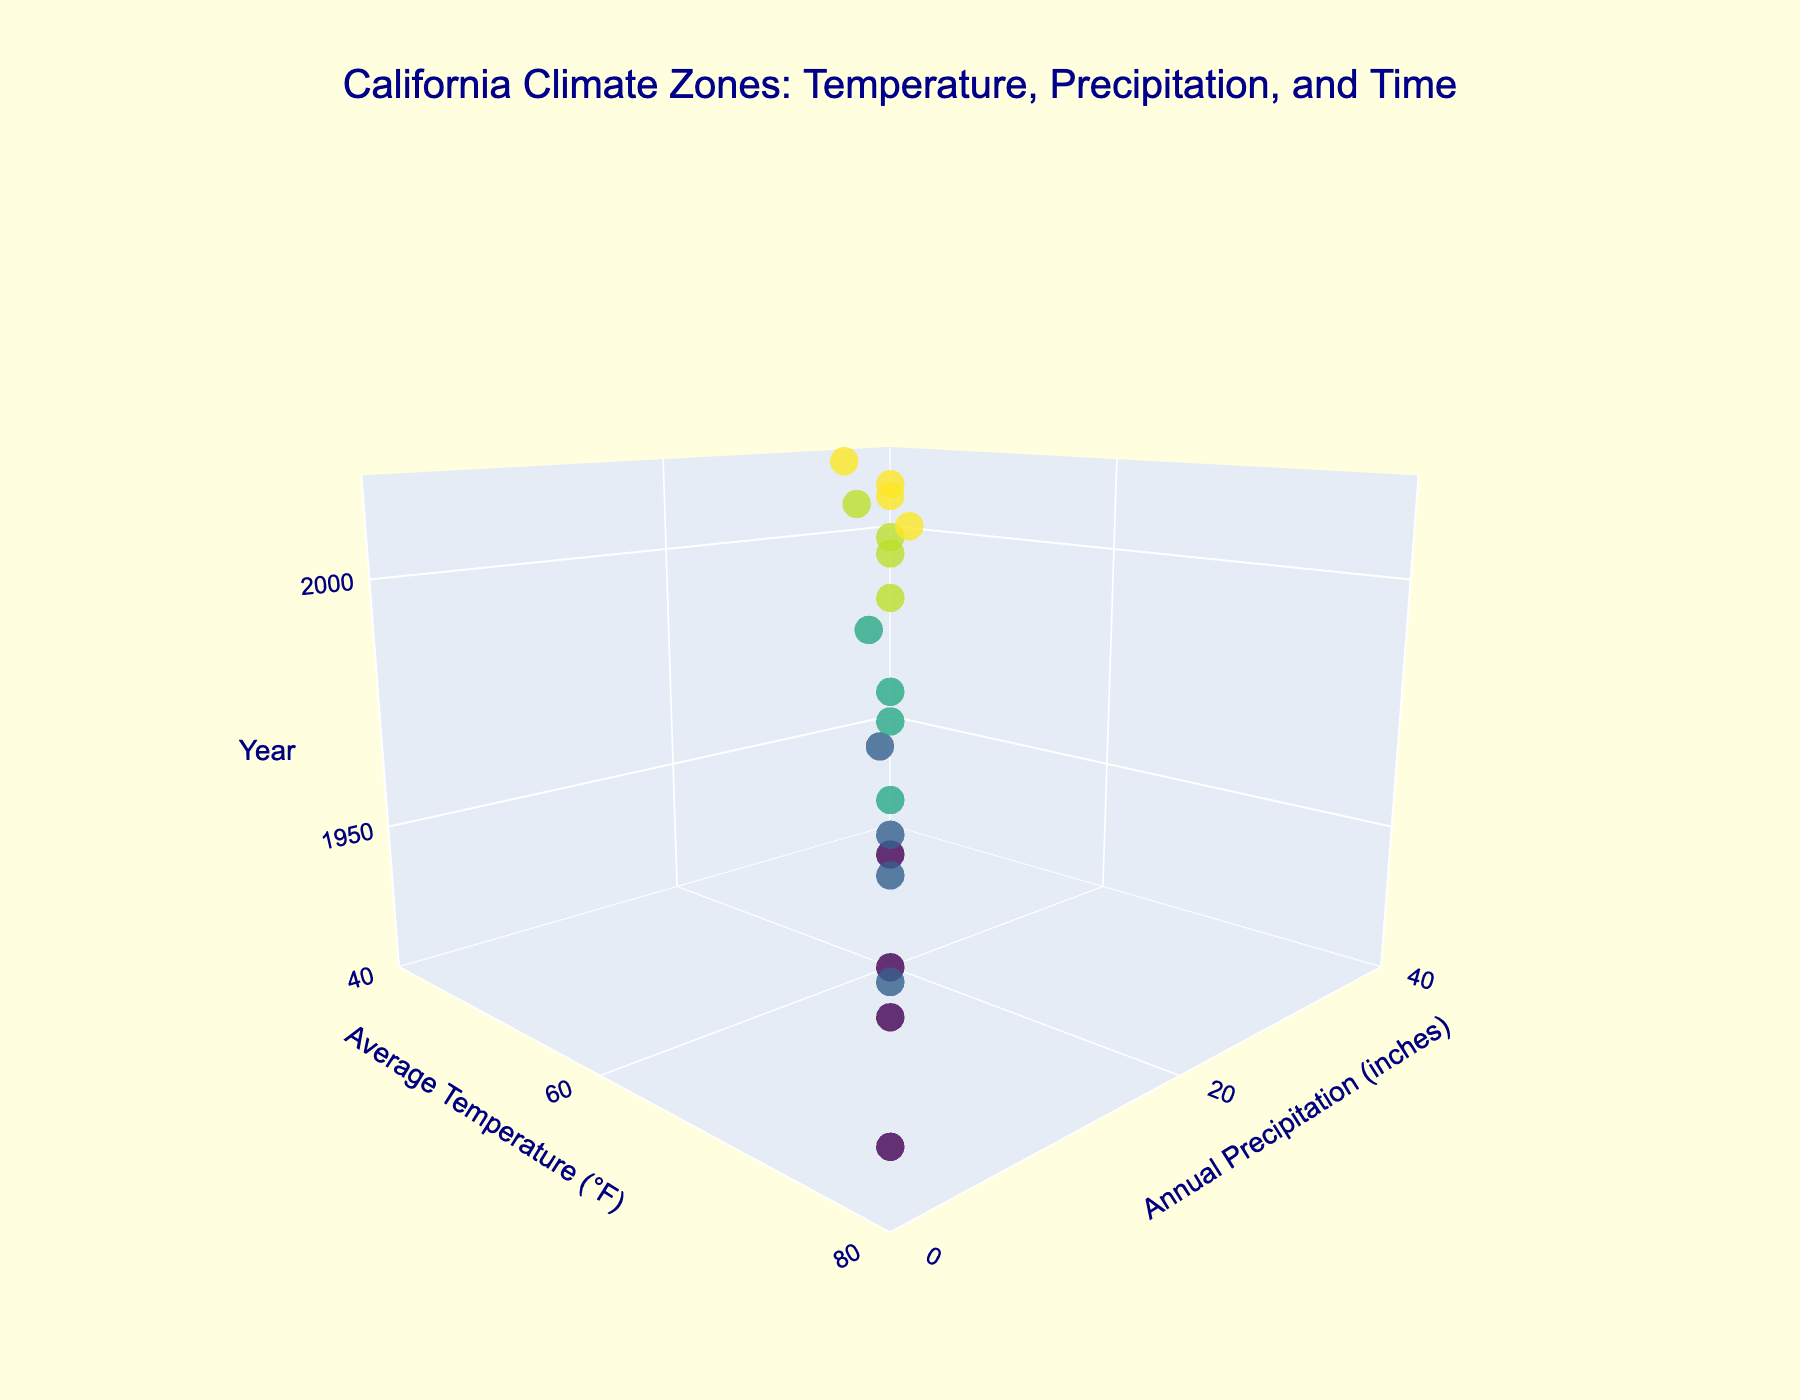What does the title of the plot indicate? The title indicates that the plot shows the relationship between temperature, precipitation, and time across California's climate zones.
Answer: California Climate Zones: Temperature, Precipitation, and Time How many climate zones are represented in the plot? The plot text shows data labels for different points, and each represents a unique climate zone. Checking the unique text labels, there are Coastal, Central Valley, Sierra Nevada, and Desert.
Answer: 4 What is the average temperature in the Desert climate zone in 2020? Locate the year 2020 along the Z-axis and identify the Desert climate zone marker in that year. The marker is at the temperature value of 79°F.
Answer: 79°F Which climate zone had the highest amount of annual precipitation in 1920? Locate the year 1920 markers along the Z-axis. The markers with maximum Y-axis value (precipitation) can be checked. The highest marker corresponds to Sierra Nevada with 35 inches of precipitation.
Answer: Sierra Nevada Compare the average temperatures in Coastal and Central Valley climate zones in 2010. Locate the markers for the year 2010 on the Z-axis for both the Coastal and Central Valley zones. The Coastal marker is at 63°F and the Central Valley marker is at 68°F.
Answer: Central Valley is higher by 5°F By how much did the average temperature in the Central Valley increase from 1920 to 2020? Locate the markers for the Central Valley in both 1920 and 2020. The values are 65°F in 1920 and 69°F in 2020. Subtracting these gives the increase 69 - 65.
Answer: 4°F Which year shows the most significant decrease in annual precipitation in the Coastal zone compared to the previous data point? Compare the annual precipitation markers for the Coastal zone over the years. The biggest drop is between 1950 (19 inches) and 1980 (18 inches).
Answer: 1950 to 1980 What trend can be observed in annual precipitation for the Sierra Nevada zone from 1920 to 2020? Check the Sierra Nevada markers across the Z-axis from 1920 to 2020. The values are 35 inches, 33 inches, 31 inches, 29 inches, and 27 inches, showing a decreasing trend.
Answer: Decreasing trend Which climate zone shows the most stable (least change) temperature over the past century? Calculate the range of temperature changes for each zone: Coastal (60 to 64), Central Valley (65 to 69), Sierra Nevada (45 to 49), Desert (75 to 79). Coastal has the smallest range (4°F).
Answer: Coastal How does the annual precipitation in the Desert zone compare across the years? Observe the Desert markers along the Y-axis: 5 inches (1920), 4 inches (1950), 3 inches (1980), 2 inches (2010 and 2020), showing a decreasing trend.
Answer: Decreasing trend 